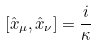<formula> <loc_0><loc_0><loc_500><loc_500>[ \hat { x } _ { \mu } , \hat { x } _ { \nu } ] = \frac { i } { \kappa }</formula> 